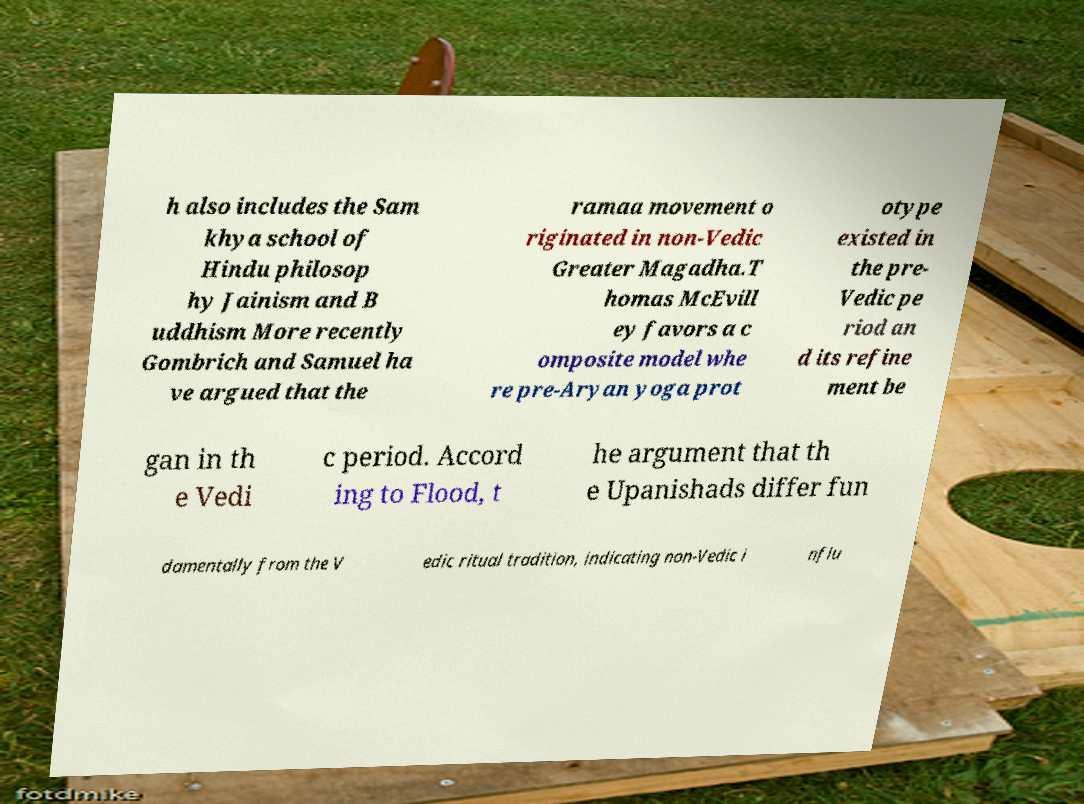I need the written content from this picture converted into text. Can you do that? h also includes the Sam khya school of Hindu philosop hy Jainism and B uddhism More recently Gombrich and Samuel ha ve argued that the ramaa movement o riginated in non-Vedic Greater Magadha.T homas McEvill ey favors a c omposite model whe re pre-Aryan yoga prot otype existed in the pre- Vedic pe riod an d its refine ment be gan in th e Vedi c period. Accord ing to Flood, t he argument that th e Upanishads differ fun damentally from the V edic ritual tradition, indicating non-Vedic i nflu 